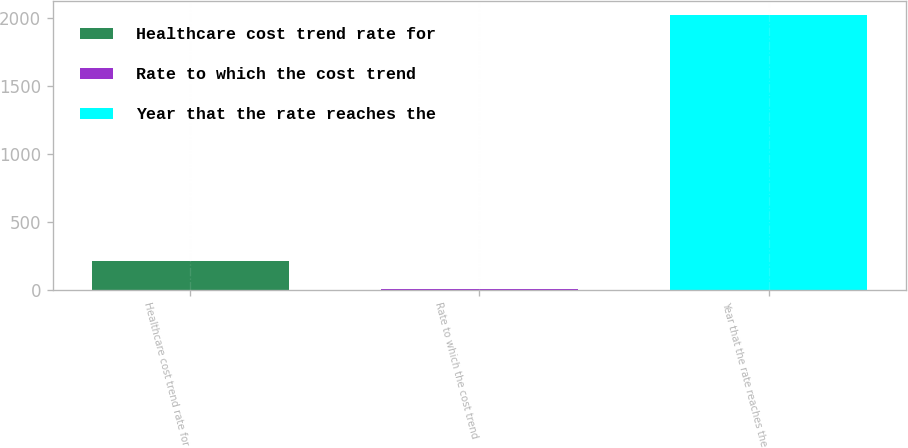Convert chart to OTSL. <chart><loc_0><loc_0><loc_500><loc_500><bar_chart><fcel>Healthcare cost trend rate for<fcel>Rate to which the cost trend<fcel>Year that the rate reaches the<nl><fcel>207.1<fcel>5<fcel>2026<nl></chart> 